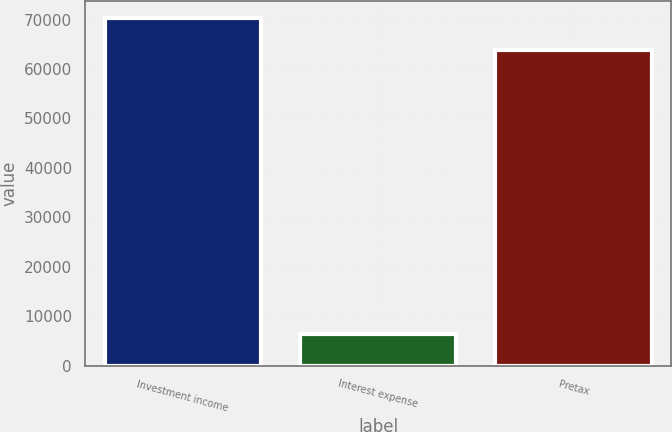<chart> <loc_0><loc_0><loc_500><loc_500><bar_chart><fcel>Investment income<fcel>Interest expense<fcel>Pretax<nl><fcel>70225.1<fcel>6384<fcel>63841<nl></chart> 